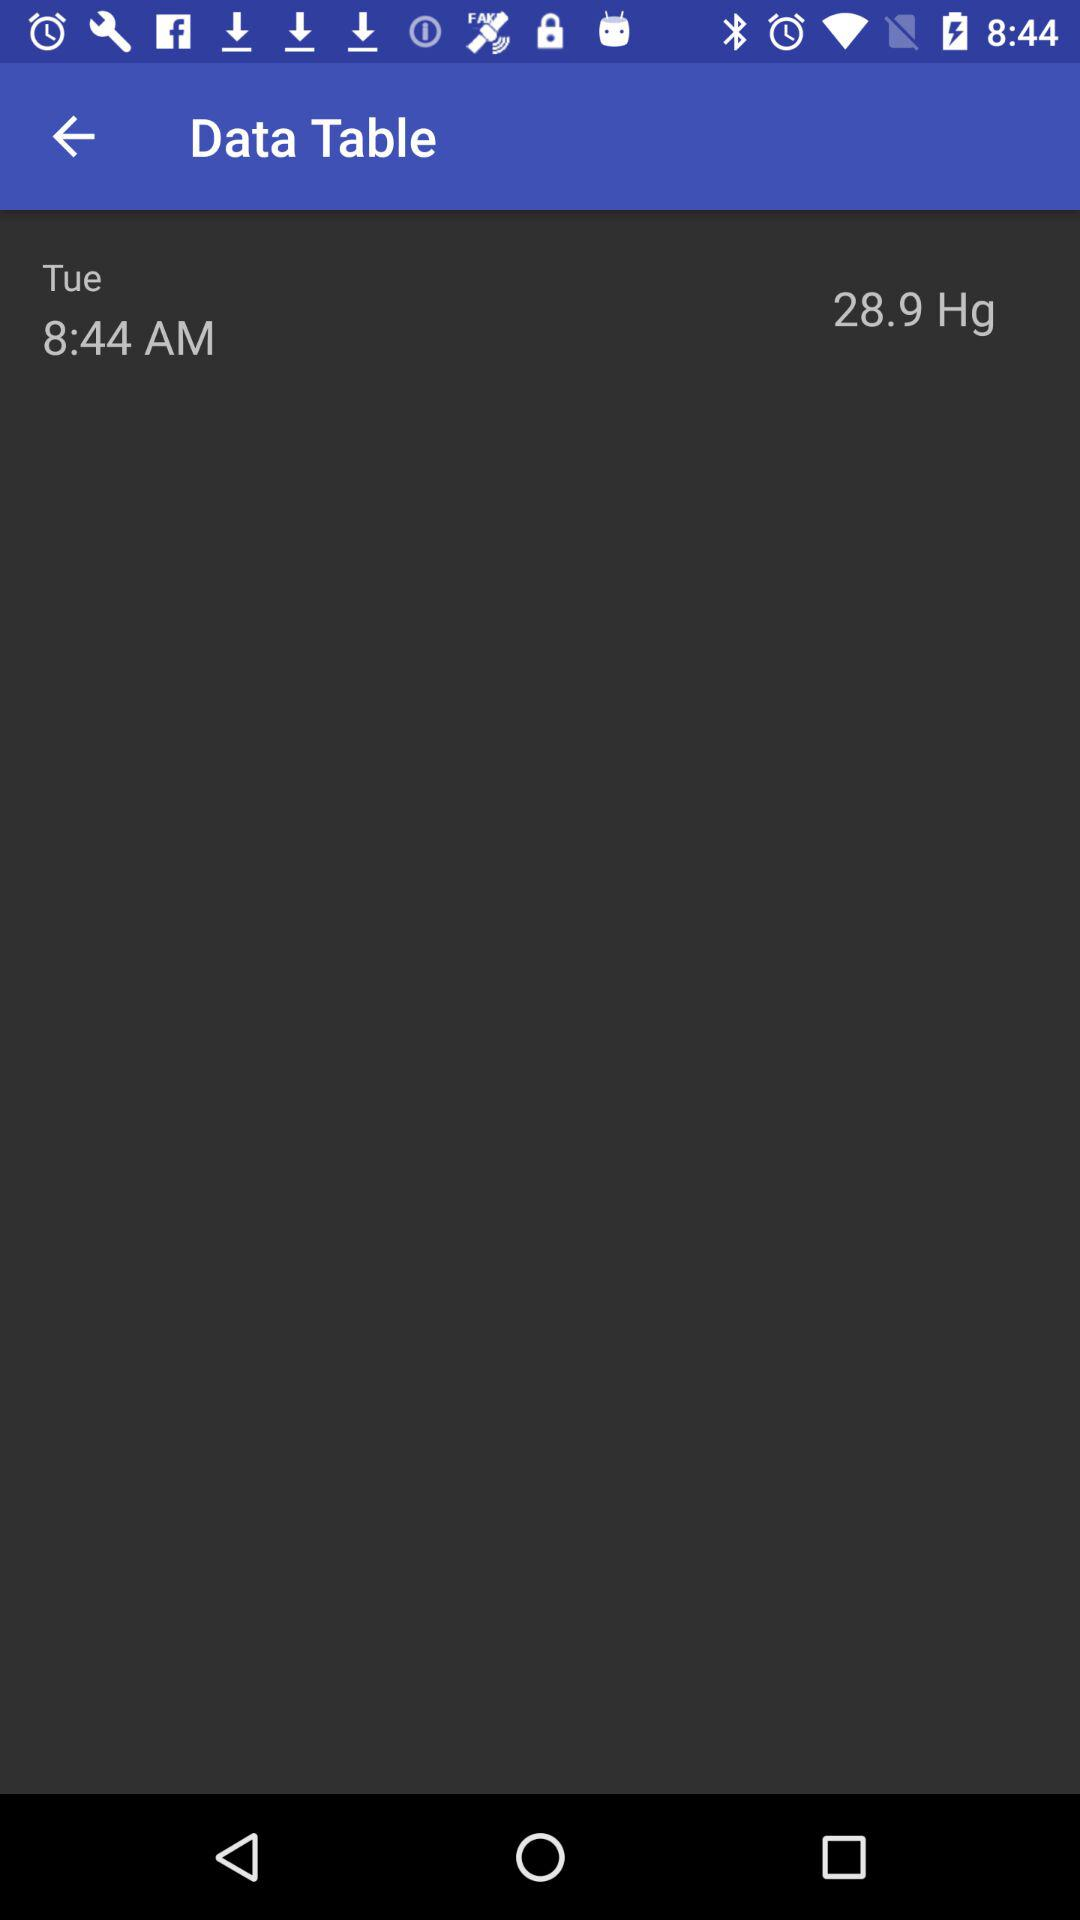What is the time shown on the screen? The time is 8:44 AM. 